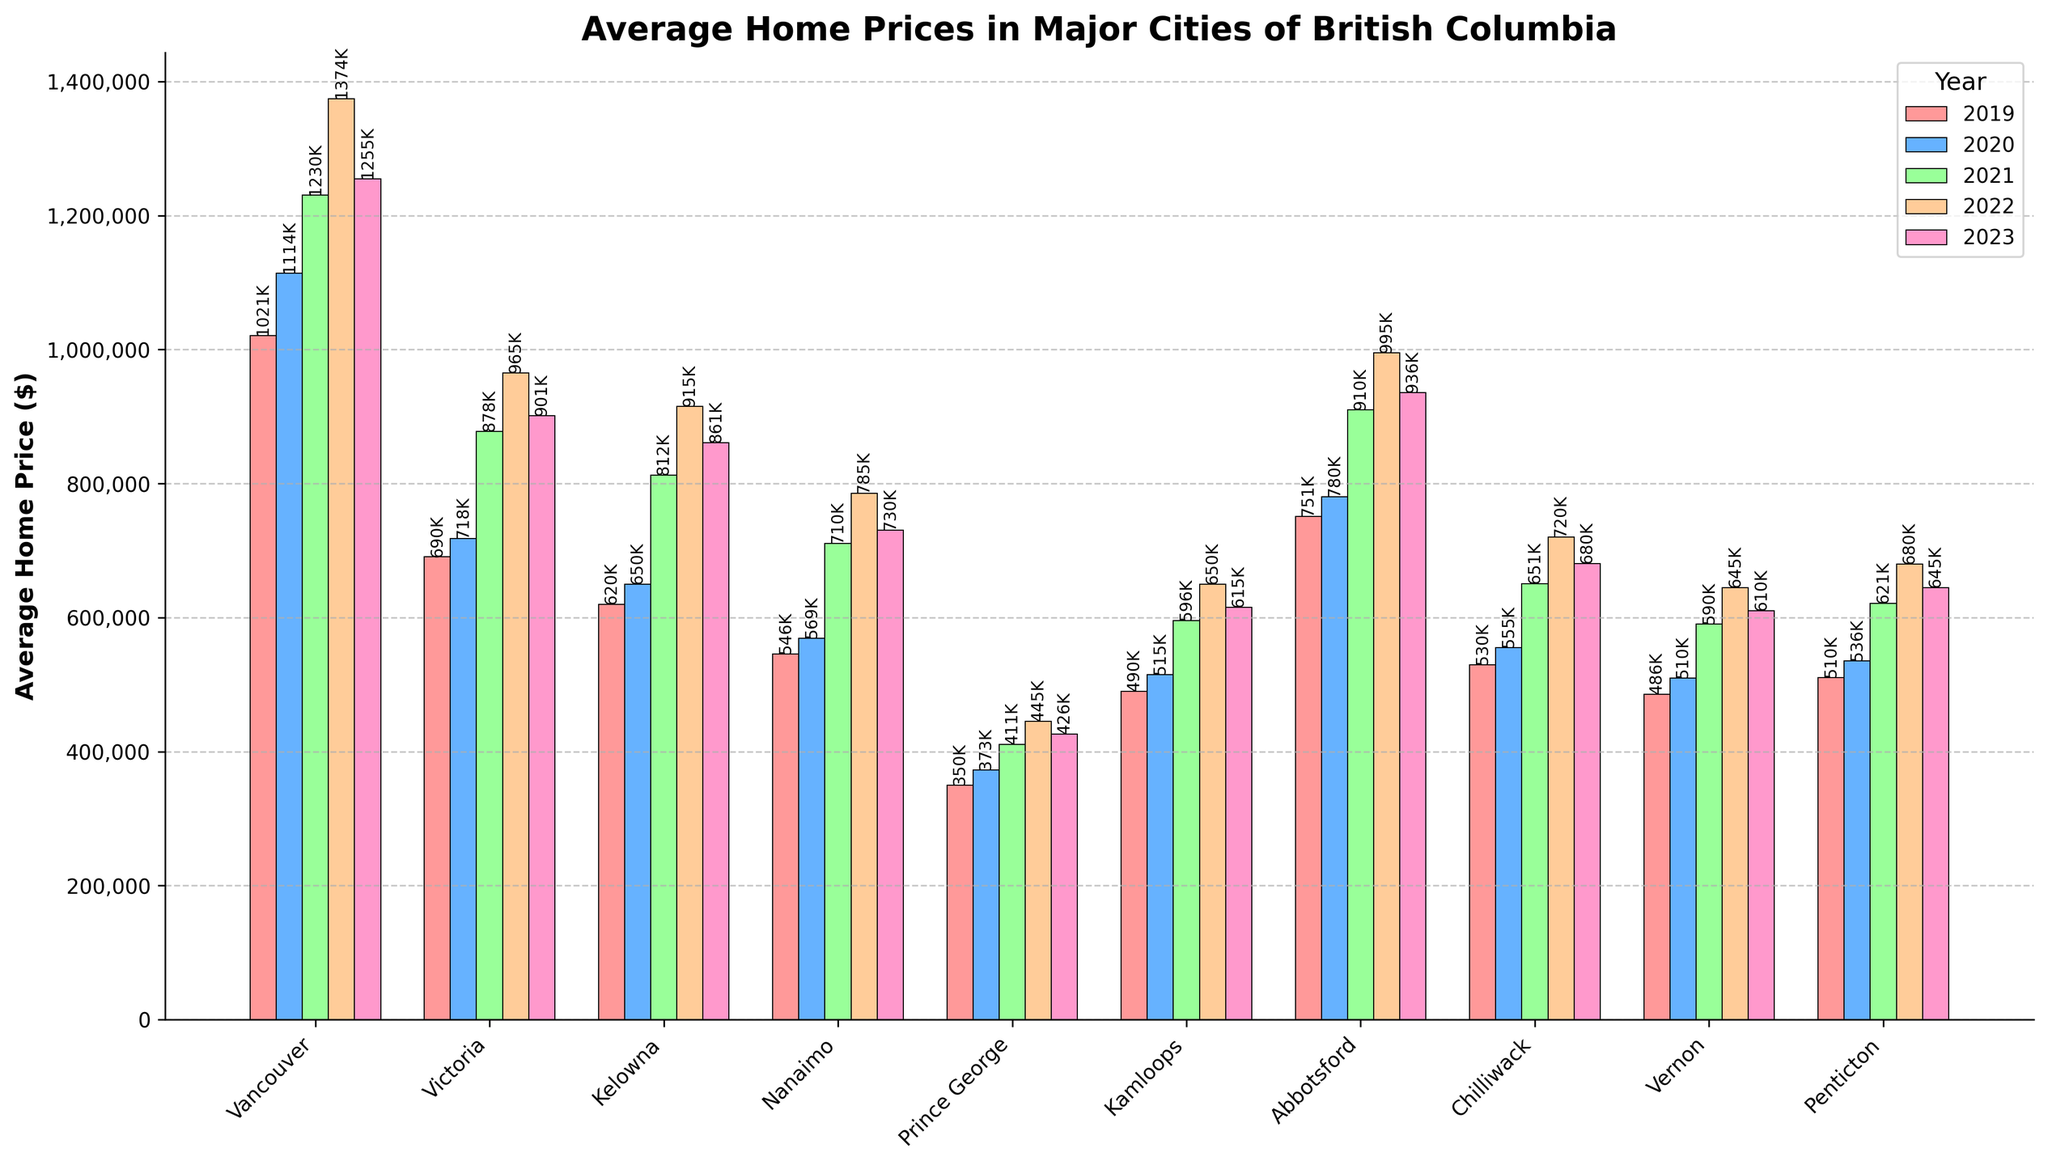What's the highest average home price among the cities over the 5-year period? To determine the highest average home price, look for the tallest bar overall in the chart. For 2022, Vancouver has the highest average home price at $1,374,500.
Answer: $1,374,500 Which city had the biggest drop in average home price from 2022 to 2023? To find the biggest drop, subtract the 2023 values from the 2022 values for each city, and compare the results. Vancouver's average home price dropped by $1,374,500 - $1,255,000 = $119,500. Compare this with other cities' drops to confirm the largest.
Answer: Vancouver How did the average home price in Victoria change between 2019 and 2023? Check the values for Victoria in 2019 and 2023; 2019 is $690,500 and 2023 is $901,200. The difference is $901,200 - $690,500 = $210,700.
Answer: Increased by $210,700 Which city had the most consistent average home price over the 5 years? Consistency implies the smallest changes year over year. Calculate the annual differences for each city and compare the range of changes. Prince George has minor changes: $350,200, $372,800, $410,600, $445,000, $425,800, indicating smaller overall fluctuations.
Answer: Prince George Among the cities listed, which one had the lowest average home price in 2023? Look at the 2023 column and identify the smallest value. Prince George has the lowest average home price in 2023 at $425,800.
Answer: Prince George How much did the average home price in Kelowna increase from 2019 to 2021? Check the values for Kelowna in 2019 and 2021; 2019 is $619,900 and 2021 is $812,500. The increase is $812,500 - $619,900 = $192,600.
Answer: $192,600 Which year had the most significant increase in average home prices for Chilliwack? Compare the year-over-year differences for Chilliwack's bar heights. From 2020 to 2021, the increase is $650,700 - $555,300 = $95,400, which is larger than other yearly changes.
Answer: 2021 What's the average home price in Abbotsford over the 5-year period? Add the yearly values for Abbotsford and divide by five: (751,200 + 780,500 + 910,200 + 995,000 + 935,600) / 5 = 874,500.
Answer: $874,500 Between Vernon and Penticton, which city had higher prices each year? Compare the yearly bar heights for Vernon and Penticton side by side. Each year (2019-2023), Penticton's prices were higher than Vernon's.
Answer: Penticton How did Nanaimo's average home price change from 2021 to 2023? Find the values for Nanaimo in 2021 and 2023; 2021 is $710,400 and 2023 is $730,500. The change is $730,500 - $710,400 = $20,100.
Answer: Increased by $20,100 